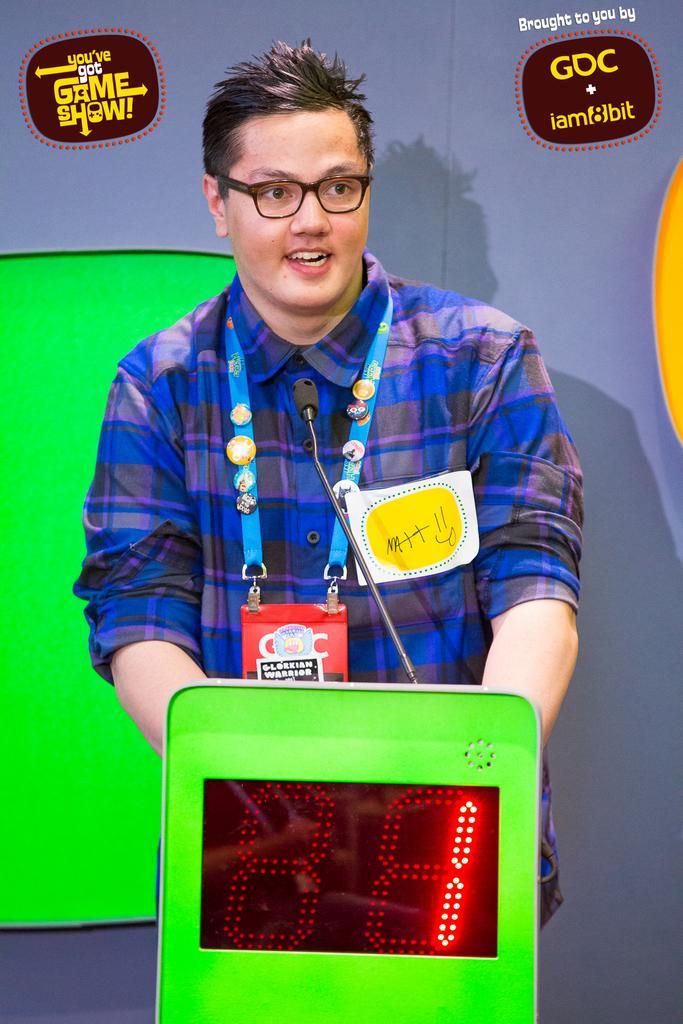In one or two sentences, can you explain what this image depicts? In this picture I see a green color thing on which there is a screen and I see a number on it and I see a mic and behind this thing I see a man who is standing and I see that he is wearing a shirt and I see the watermarks on the top of this image. 